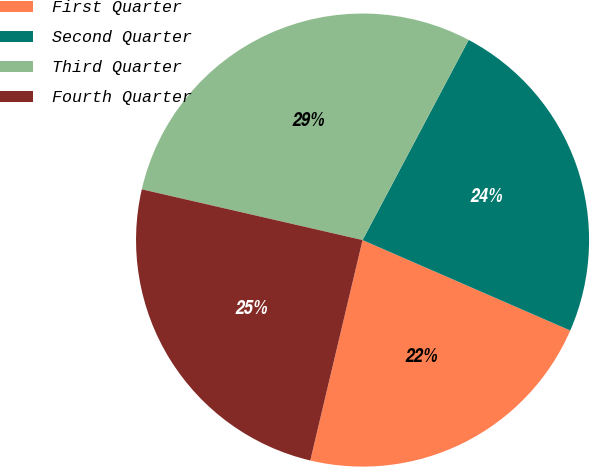<chart> <loc_0><loc_0><loc_500><loc_500><pie_chart><fcel>First Quarter<fcel>Second Quarter<fcel>Third Quarter<fcel>Fourth Quarter<nl><fcel>22.17%<fcel>23.78%<fcel>29.16%<fcel>24.89%<nl></chart> 